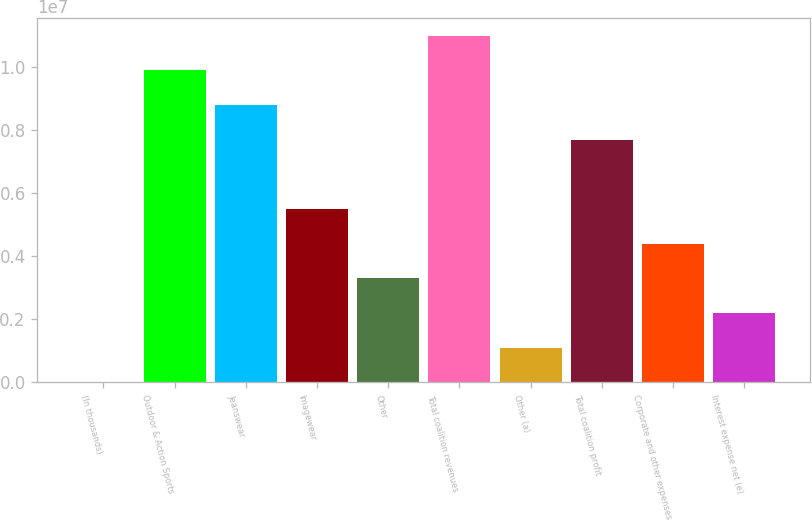<chart> <loc_0><loc_0><loc_500><loc_500><bar_chart><fcel>(In thousands)<fcel>Outdoor & Action Sports<fcel>Jeanswear<fcel>Imagewear<fcel>Other<fcel>Total coalition revenues<fcel>Other (a)<fcel>Total coalition profit<fcel>Corporate and other expenses<fcel>Interest expense net (e)<nl><fcel>2015<fcel>9.89696e+06<fcel>8.79752e+06<fcel>5.4992e+06<fcel>3.30033e+06<fcel>1.09964e+07<fcel>1.10145e+06<fcel>7.69808e+06<fcel>4.39977e+06<fcel>2.20089e+06<nl></chart> 